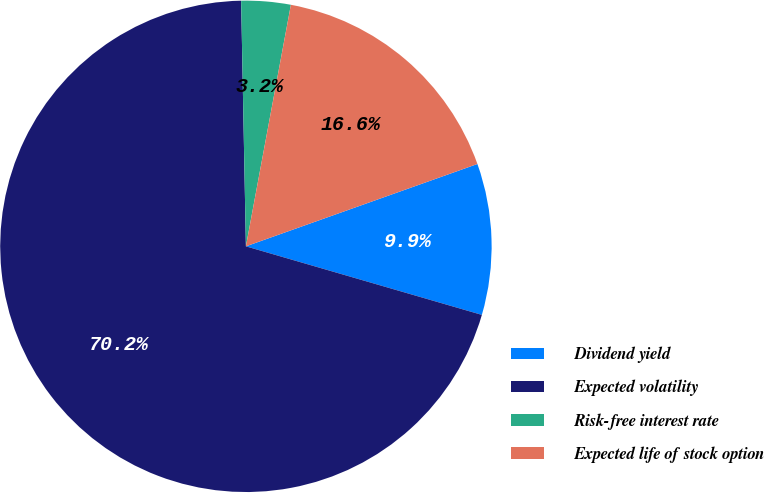Convert chart. <chart><loc_0><loc_0><loc_500><loc_500><pie_chart><fcel>Dividend yield<fcel>Expected volatility<fcel>Risk-free interest rate<fcel>Expected life of stock option<nl><fcel>9.94%<fcel>70.19%<fcel>3.24%<fcel>16.63%<nl></chart> 